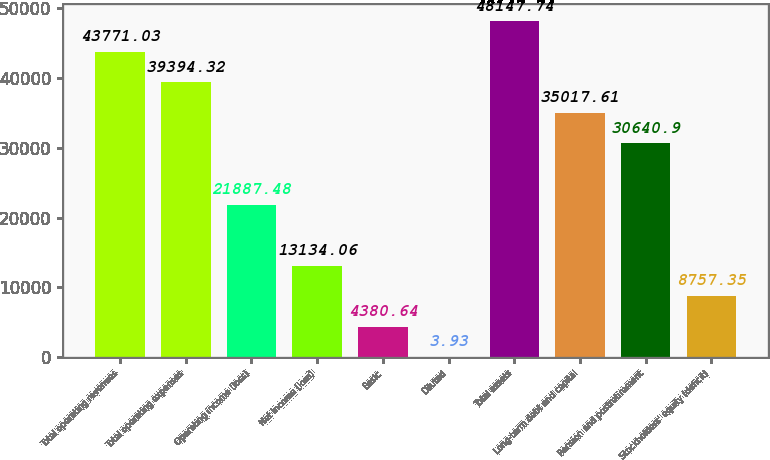<chart> <loc_0><loc_0><loc_500><loc_500><bar_chart><fcel>Total operating revenues<fcel>Total operating expenses<fcel>Operating income (loss)<fcel>Net income (loss)<fcel>Basic<fcel>Diluted<fcel>Total assets<fcel>Long-term debt and capital<fcel>Pension and postretirement<fcel>Stockholders' equity (deficit)<nl><fcel>43771<fcel>39394.3<fcel>21887.5<fcel>13134.1<fcel>4380.64<fcel>3.93<fcel>48147.7<fcel>35017.6<fcel>30640.9<fcel>8757.35<nl></chart> 